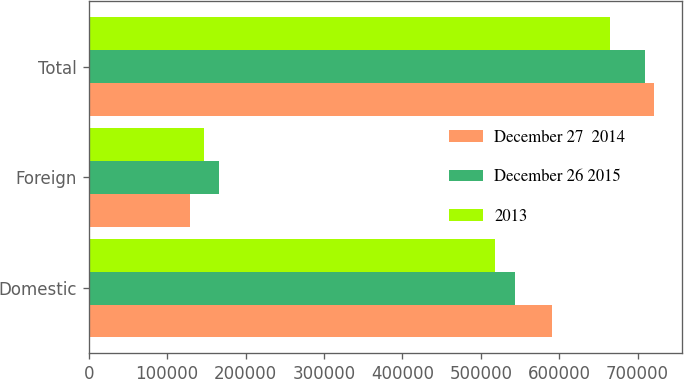<chart> <loc_0><loc_0><loc_500><loc_500><stacked_bar_chart><ecel><fcel>Domestic<fcel>Foreign<fcel>Total<nl><fcel>December 27  2014<fcel>591320<fcel>129438<fcel>720758<nl><fcel>December 26 2015<fcel>543433<fcel>165879<fcel>709312<nl><fcel>2013<fcel>517950<fcel>146744<fcel>664694<nl></chart> 